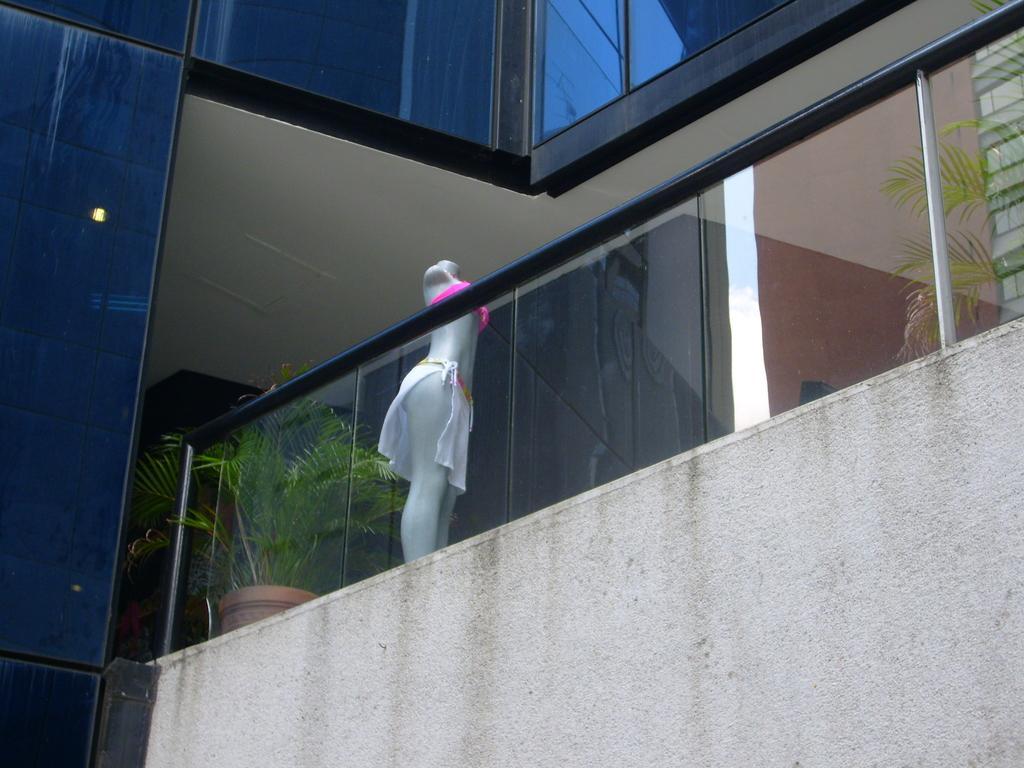How would you summarize this image in a sentence or two? In the foreground of this picture, there is a wall and a railing. Behind railing, there are plants and a mannequin. On the top, there is wall of a building. 